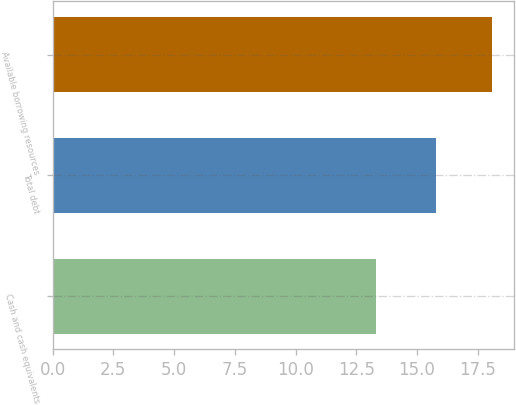Convert chart. <chart><loc_0><loc_0><loc_500><loc_500><bar_chart><fcel>Cash and cash equivalents<fcel>Total debt<fcel>Available borrowing resources<nl><fcel>13.3<fcel>15.8<fcel>18.1<nl></chart> 